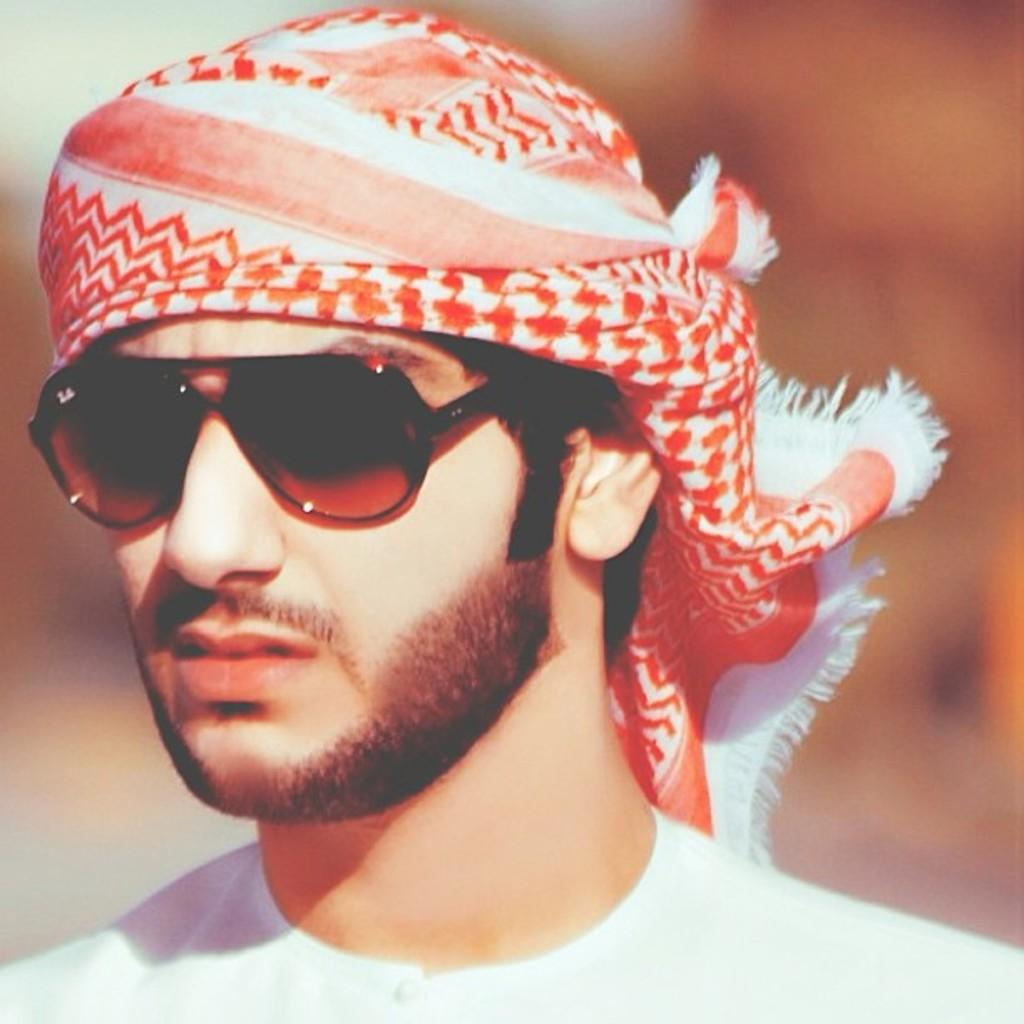Who is present in the image? There is a man in the image. What is the man wearing? The man is wearing clothes and goggles. Can you describe the background of the image? The background of the image is blurred. What type of education does the man have in the image? There is no information about the man's education in the image. 